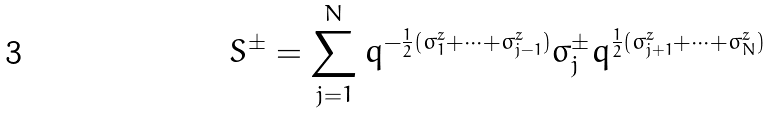<formula> <loc_0><loc_0><loc_500><loc_500>S ^ { \pm } = \sum _ { j = 1 } ^ { N } q ^ { - \frac { 1 } { 2 } ( \sigma _ { 1 } ^ { z } + \dots + \sigma _ { j - 1 } ^ { z } ) } \sigma _ { j } ^ { \pm } q ^ { \frac { 1 } { 2 } ( \sigma _ { j + 1 } ^ { z } + \dots + \sigma _ { N } ^ { z } ) }</formula> 